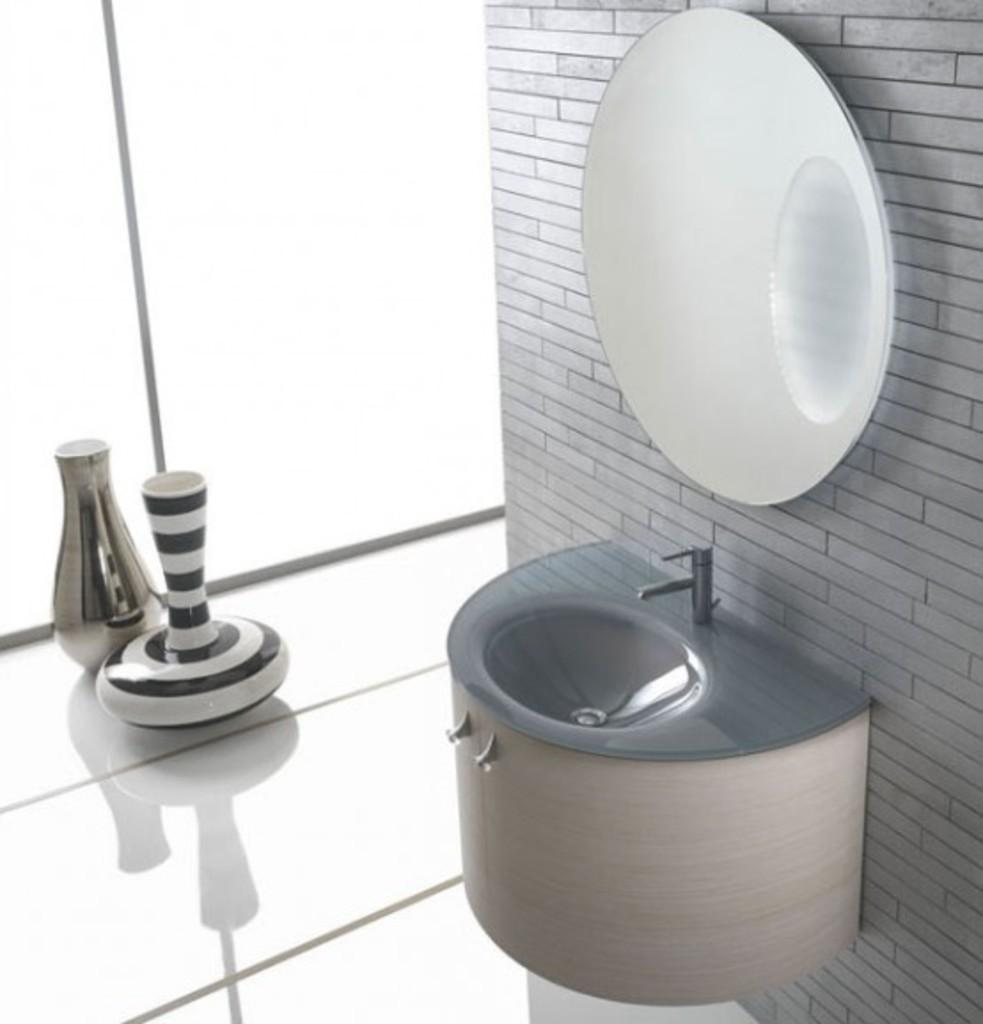What can be found in the image for washing hands? There is a sink in the image for washing hands. What is placed on the wall in the image? There is a mirror placed on the wall in the image. What objects are placed on the left side of the image? There are vases placed on the surface on the left side in the image. What can be seen in the background of the image? There is a wall in the background of the image. Can you tell me how many jewels are placed on the elbow in the image? There are no jewels or elbows present in the image; the objects mentioned are a sink, a mirror, vases, and a wall. 